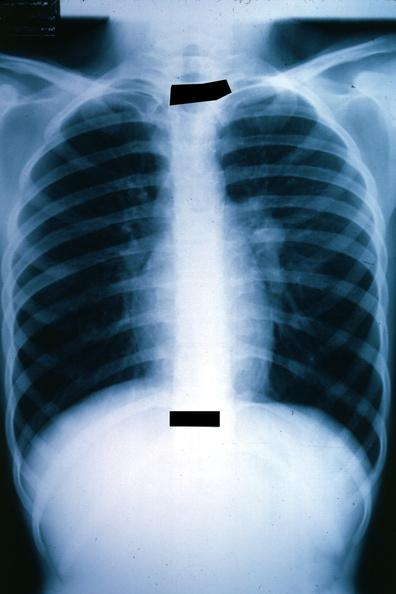s median lobe hyperplasia with marked cystitis and bladder hypertrophy ureter present?
Answer the question using a single word or phrase. No 